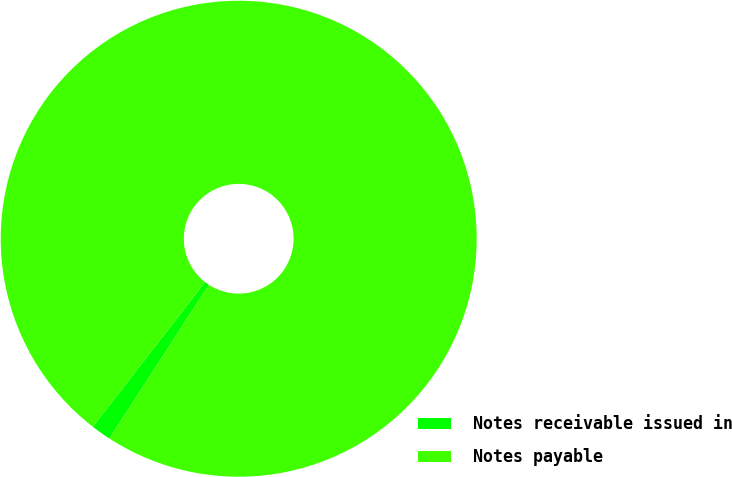<chart> <loc_0><loc_0><loc_500><loc_500><pie_chart><fcel>Notes receivable issued in<fcel>Notes payable<nl><fcel>1.36%<fcel>98.64%<nl></chart> 